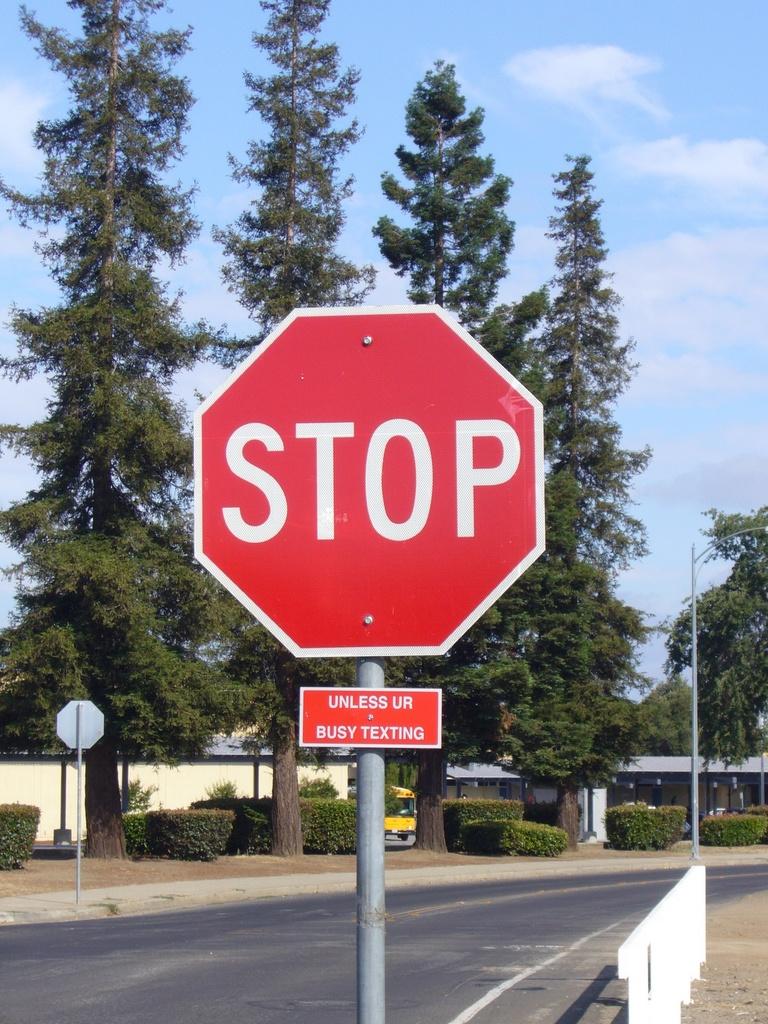What does the bottom sign say?
Make the answer very short. Unless ur busy texting. What color is the stop sign?
Make the answer very short. Answering does not require reading text in the image. 